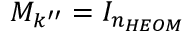<formula> <loc_0><loc_0><loc_500><loc_500>M _ { k ^ { \prime \prime } } = I _ { n _ { H E O M } }</formula> 